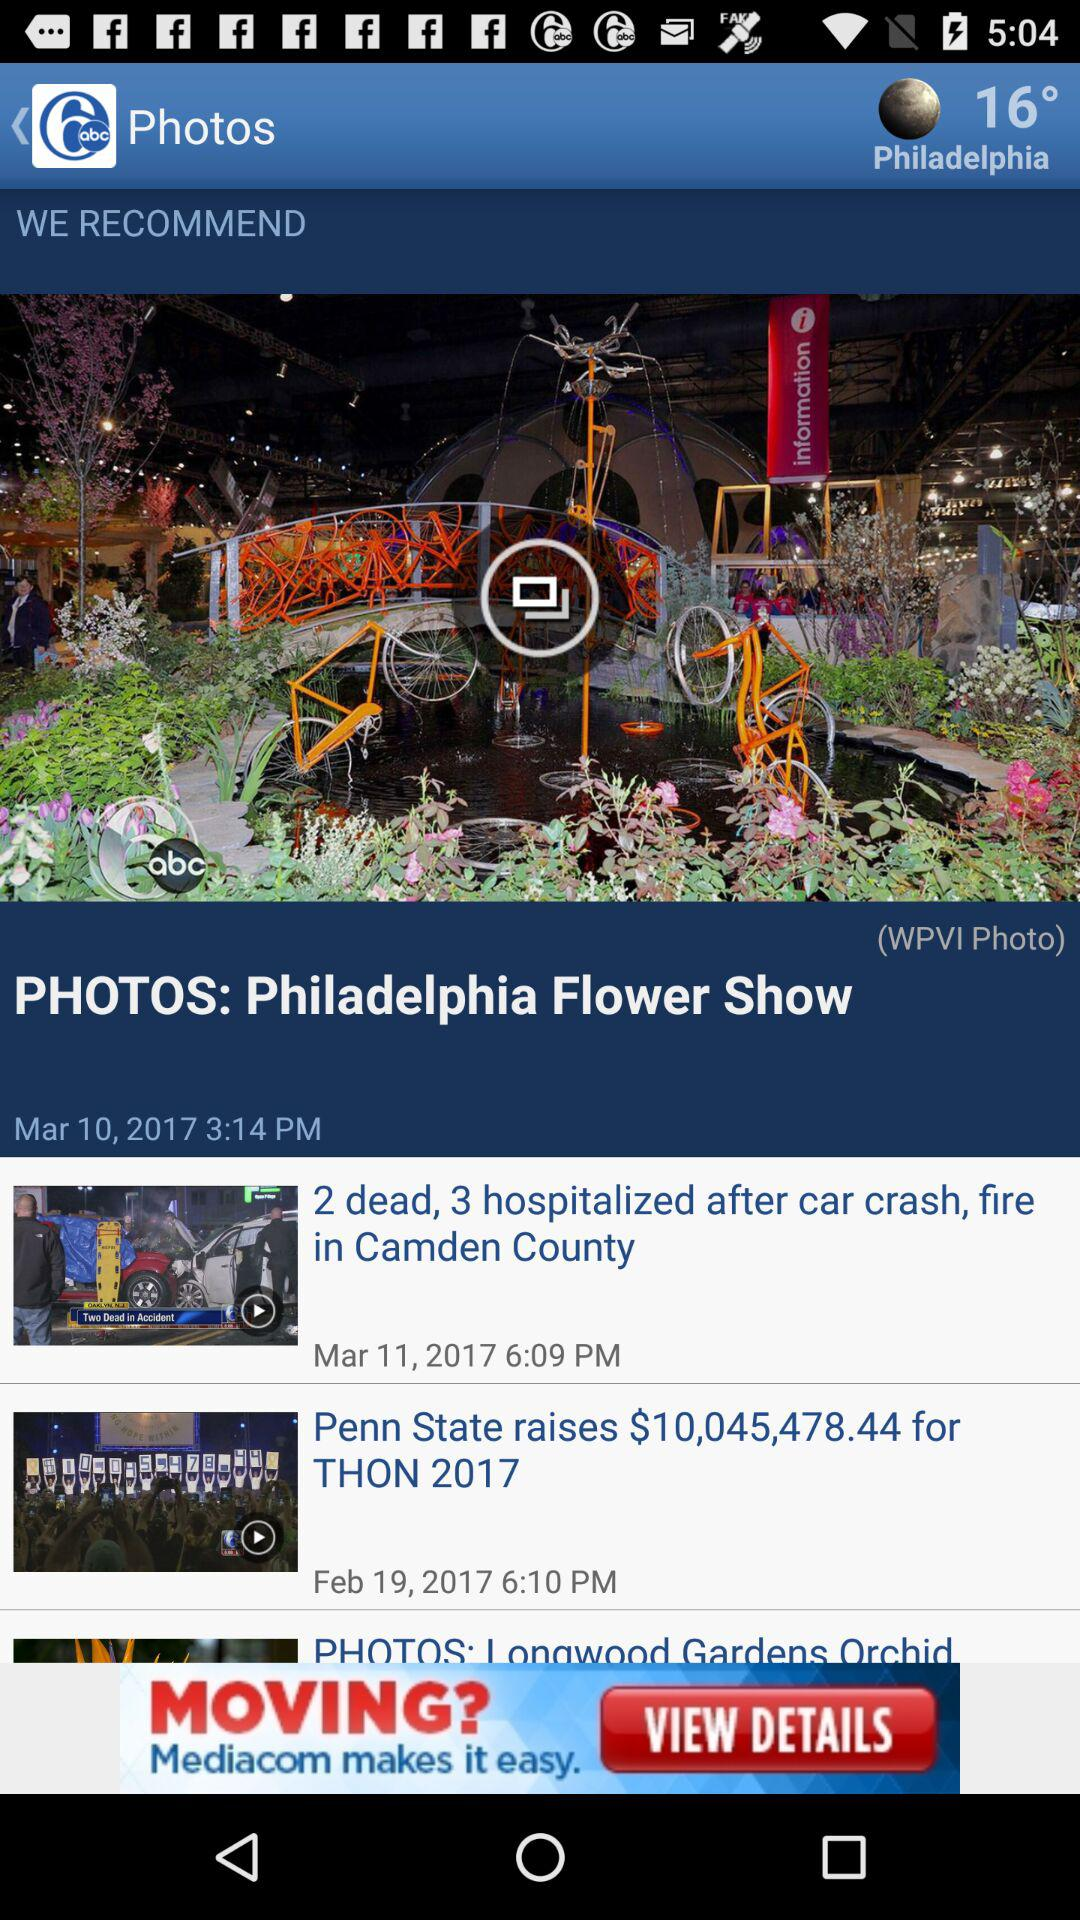What is the date and time given for the Philadelphia Flower Show? The date and time given for the Philadelphia Flower Show is March 10, 2017 at 3:14 pm. 